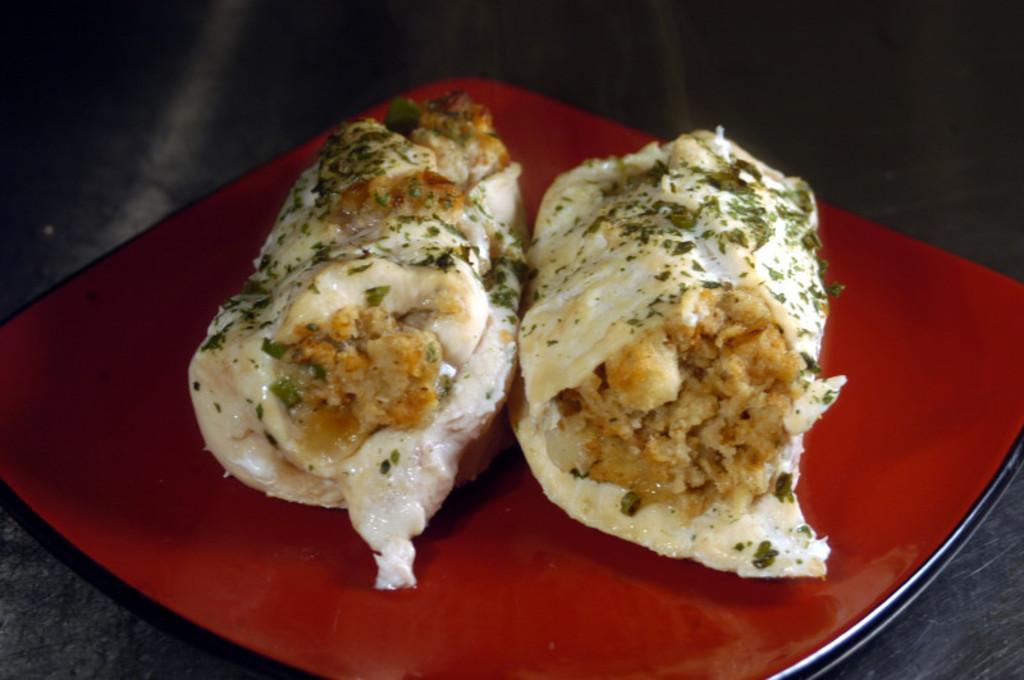Please provide a concise description of this image. We can see plate with food on the platform. 